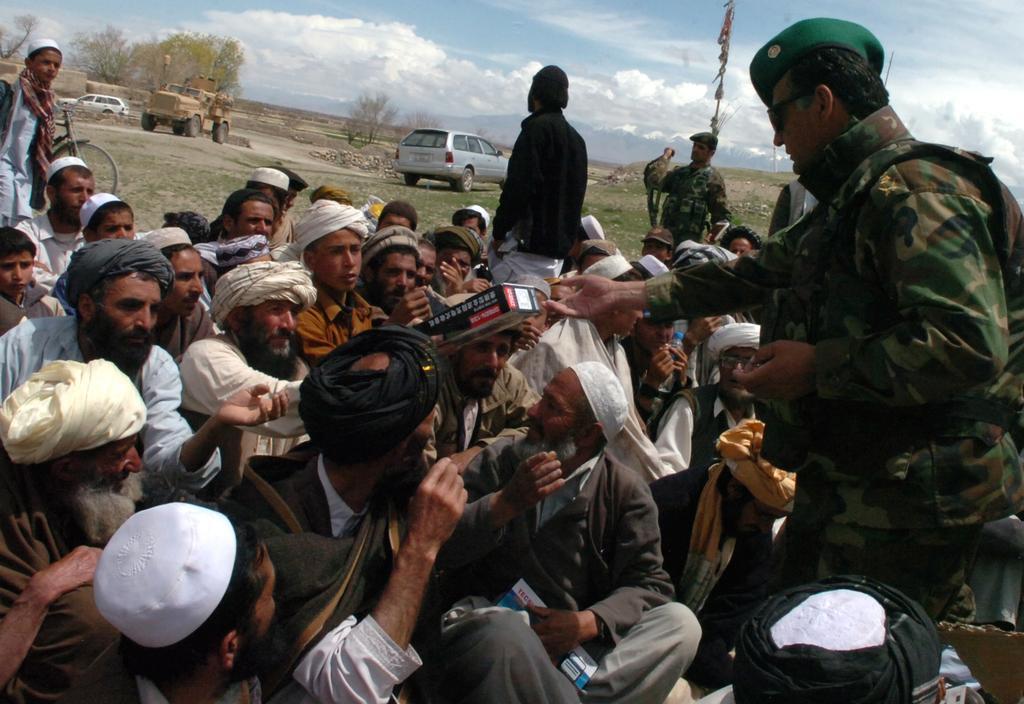Can you describe this image briefly? In front of the image there are a few people sitting and there are a few people standing. In the background of the image there are vehicles, trees. At the top of the image there are clouds in the sky. 